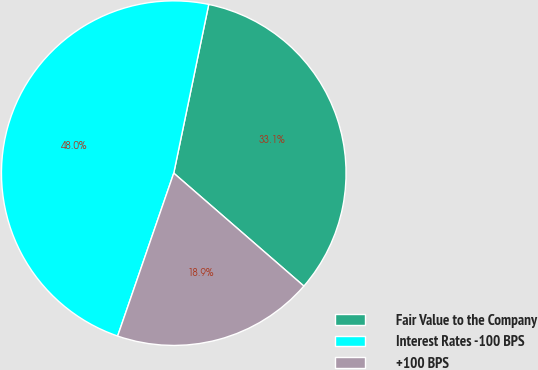<chart> <loc_0><loc_0><loc_500><loc_500><pie_chart><fcel>Fair Value to the Company<fcel>Interest Rates -100 BPS<fcel>+100 BPS<nl><fcel>33.12%<fcel>47.97%<fcel>18.9%<nl></chart> 